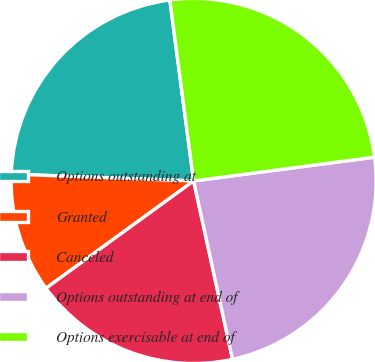Convert chart to OTSL. <chart><loc_0><loc_0><loc_500><loc_500><pie_chart><fcel>Options outstanding at<fcel>Granted<fcel>Canceled<fcel>Options outstanding at end of<fcel>Options exercisable at end of<nl><fcel>22.32%<fcel>10.6%<fcel>18.42%<fcel>23.66%<fcel>25.0%<nl></chart> 